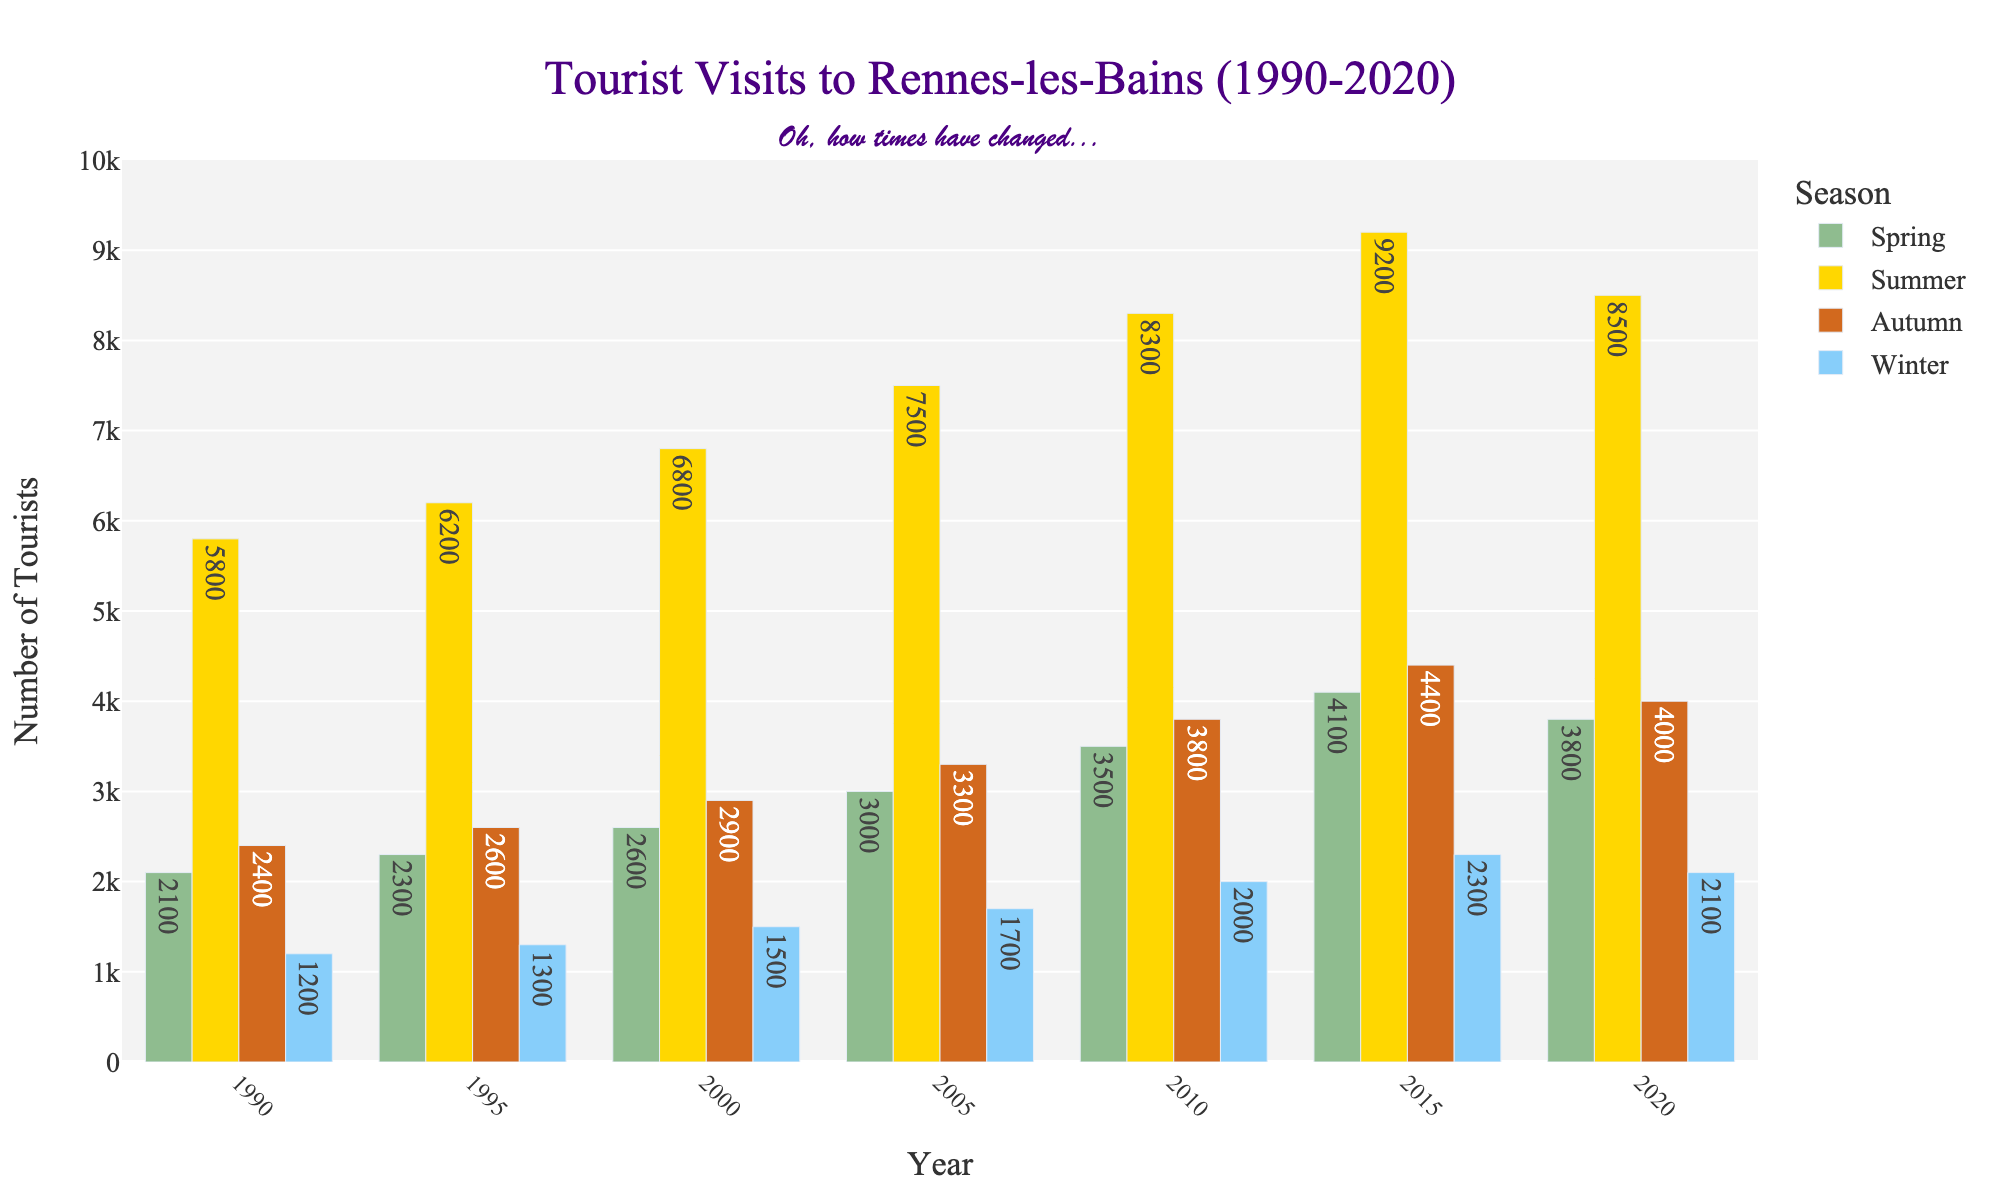Which season had the highest number of tourists in 2015? Look for the tallest bar in 2015 and note the season it represents. The highest bar for 2015 is for Summer.
Answer: Summer How did the number of tourists in Spring compare from 1990 to 2020? Compare the heights of the bars representing Spring in 1990 and 2020. In 1990, there are 2,100 tourists, and in 2020, there are 3,800 tourists, showing an increase.
Answer: Increased Which year observed the highest number of tourists in Winter? Look for the highest bar in the Winter category across all years. The tallest Winter bar is for 2015 with 2,300 tourists.
Answer: 2015 What is the average number of tourists visiting in Autumn from 1990 to 2020? Add up the number of tourists for Autumn in each year and divide by the number of years. (2400 + 2600 + 2900 + 3300 + 3800 + 4400 + 4000) / 7 = 3,485.7
Answer: 3485.7 Did the number of tourists in Summer increase or decrease between 2015 and 2020? Compare the heights of the Summer bars for 2015 and 2020. In 2015, there are 9,200 tourists, and in 2020, there are 8,500 tourists, indicating a decrease.
Answer: Decreased Which season showed the most consistent growth in tourist numbers over the three decades? Look at the trends for all seasons. The Spring season shows a consistent upward trend without any dips.
Answer: Spring How much did the number of tourists in Winter increase from 1990 to 2010? Subtract the number of tourists in Winter in 1990 from the number in 2010: 2,000 - 1,200 = 800.
Answer: 800 What is the total number of tourists visited in 2000 across all seasons? Add the number of tourists for each season in 2000: 2,600 (Spring) + 6,800 (Summer) + 2,900 (Autumn) + 1,500 (Winter) = 13,800.
Answer: 13800 How does the Spring of 1995 compare to the Winter of 2015 in terms of tourist numbers? Compare the bars for Spring of 1995 and Winter of 2015. Spring of 1995 has 2,300 tourists, while Winter of 2015 has 2,300 tourists – they are equal.
Answer: Equal 